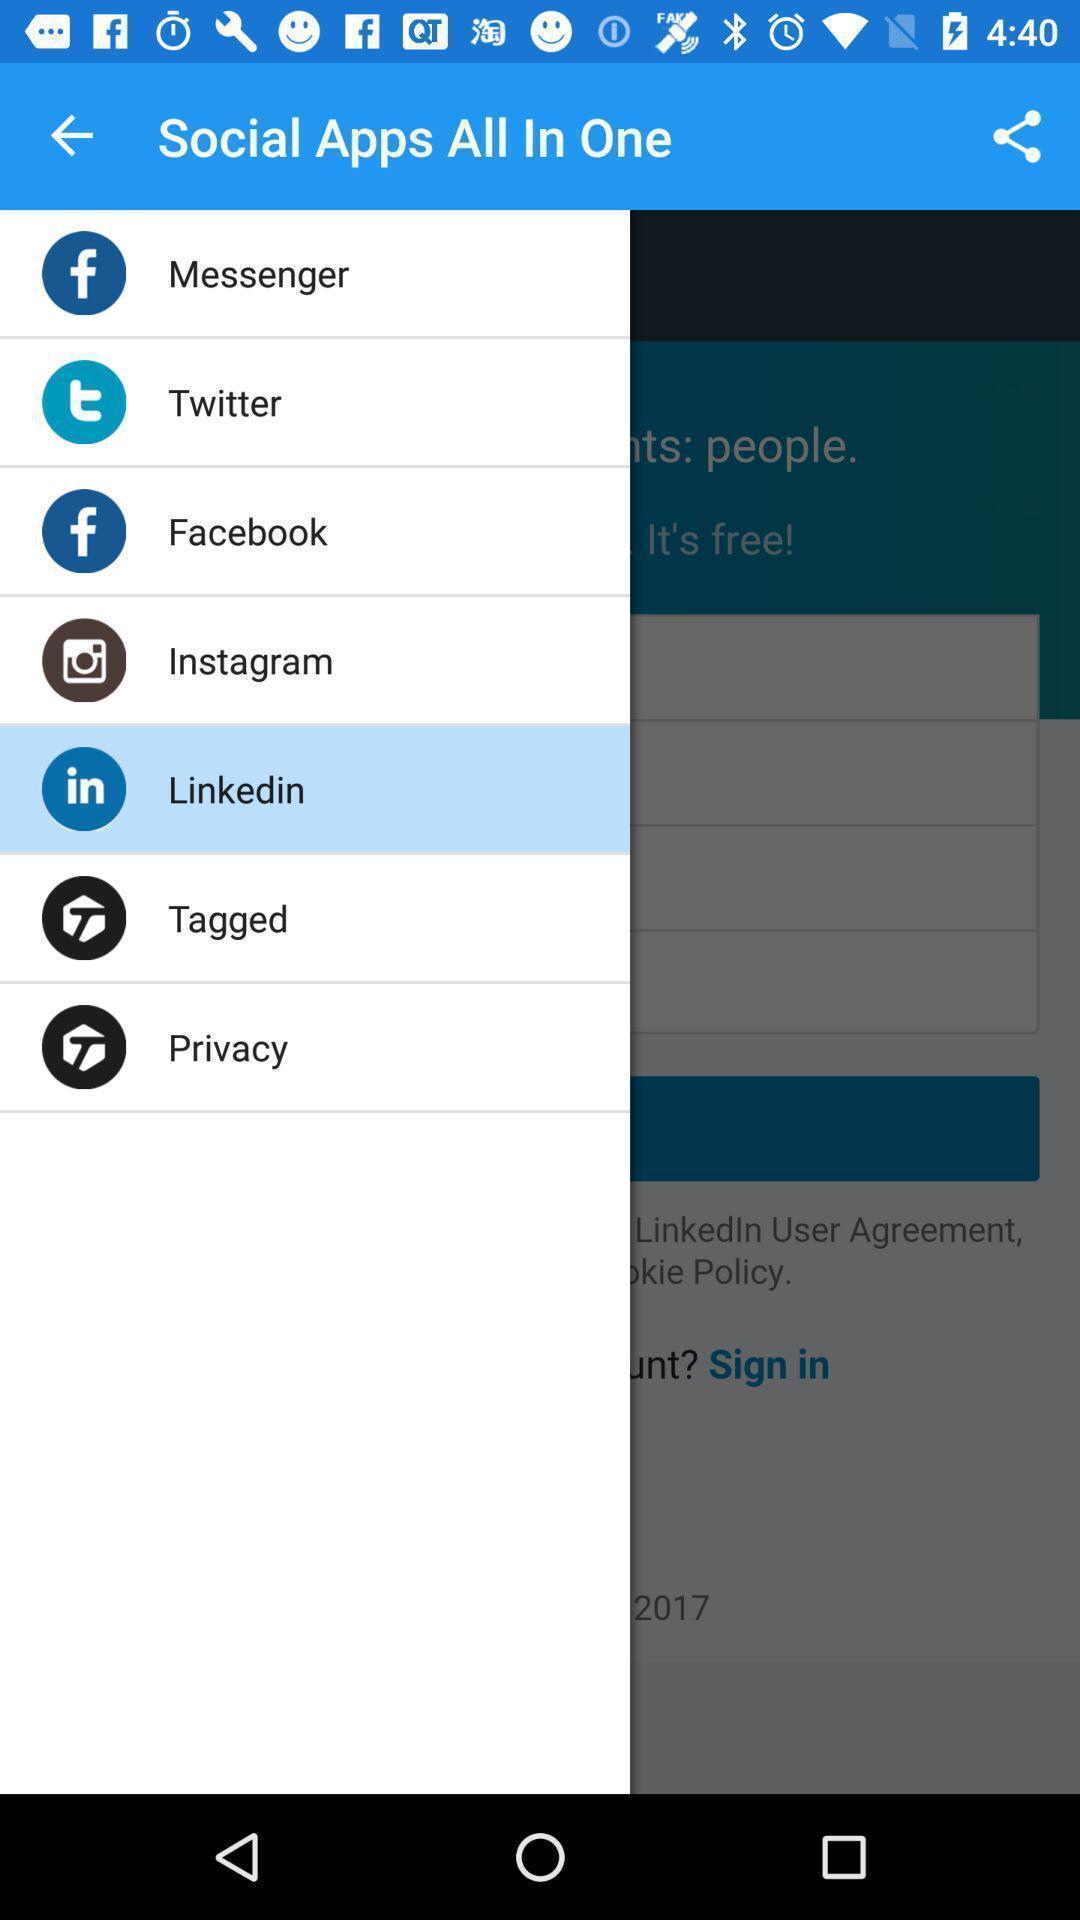Tell me about the visual elements in this screen capture. Page showing list of social apps on an app. 